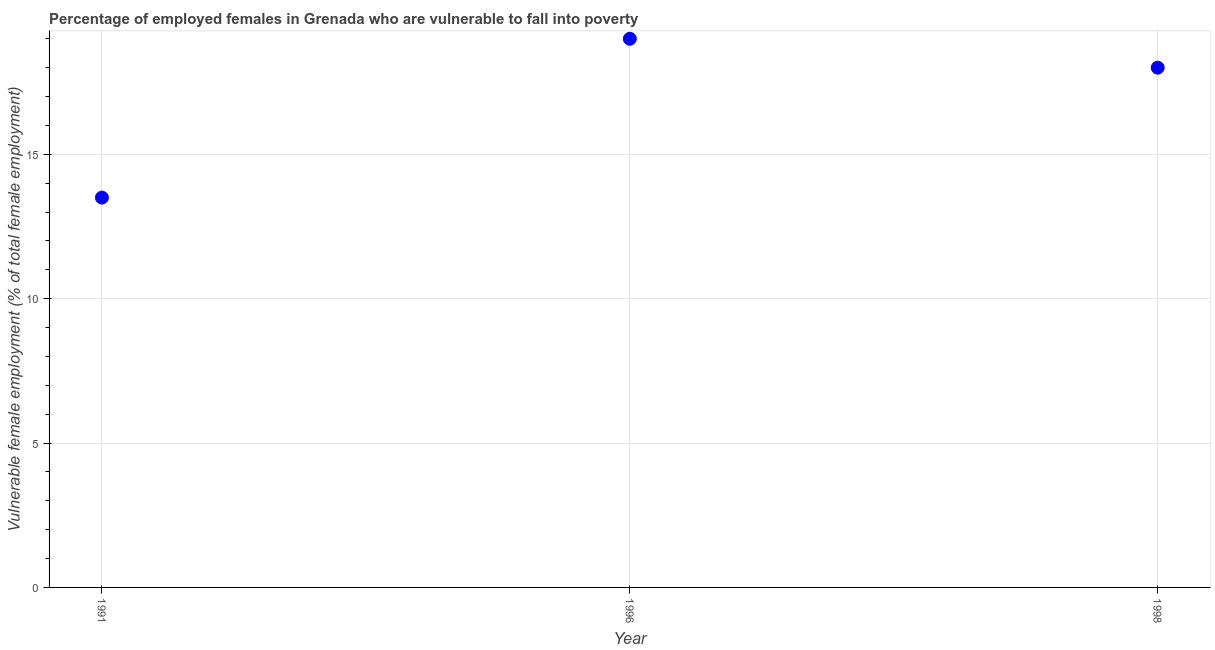What is the percentage of employed females who are vulnerable to fall into poverty in 1998?
Ensure brevity in your answer.  18. Across all years, what is the maximum percentage of employed females who are vulnerable to fall into poverty?
Provide a succinct answer. 19. Across all years, what is the minimum percentage of employed females who are vulnerable to fall into poverty?
Make the answer very short. 13.5. In which year was the percentage of employed females who are vulnerable to fall into poverty maximum?
Ensure brevity in your answer.  1996. What is the sum of the percentage of employed females who are vulnerable to fall into poverty?
Keep it short and to the point. 50.5. What is the average percentage of employed females who are vulnerable to fall into poverty per year?
Your response must be concise. 16.83. What is the ratio of the percentage of employed females who are vulnerable to fall into poverty in 1991 to that in 1996?
Your answer should be very brief. 0.71. Is the percentage of employed females who are vulnerable to fall into poverty in 1991 less than that in 1998?
Provide a short and direct response. Yes. Is the difference between the percentage of employed females who are vulnerable to fall into poverty in 1996 and 1998 greater than the difference between any two years?
Offer a terse response. No. What is the difference between the highest and the lowest percentage of employed females who are vulnerable to fall into poverty?
Keep it short and to the point. 5.5. Are the values on the major ticks of Y-axis written in scientific E-notation?
Ensure brevity in your answer.  No. Does the graph contain grids?
Keep it short and to the point. Yes. What is the title of the graph?
Your answer should be very brief. Percentage of employed females in Grenada who are vulnerable to fall into poverty. What is the label or title of the X-axis?
Your answer should be very brief. Year. What is the label or title of the Y-axis?
Offer a very short reply. Vulnerable female employment (% of total female employment). What is the difference between the Vulnerable female employment (% of total female employment) in 1991 and 1996?
Provide a short and direct response. -5.5. What is the difference between the Vulnerable female employment (% of total female employment) in 1991 and 1998?
Your answer should be very brief. -4.5. What is the difference between the Vulnerable female employment (% of total female employment) in 1996 and 1998?
Offer a terse response. 1. What is the ratio of the Vulnerable female employment (% of total female employment) in 1991 to that in 1996?
Offer a terse response. 0.71. What is the ratio of the Vulnerable female employment (% of total female employment) in 1996 to that in 1998?
Offer a terse response. 1.06. 